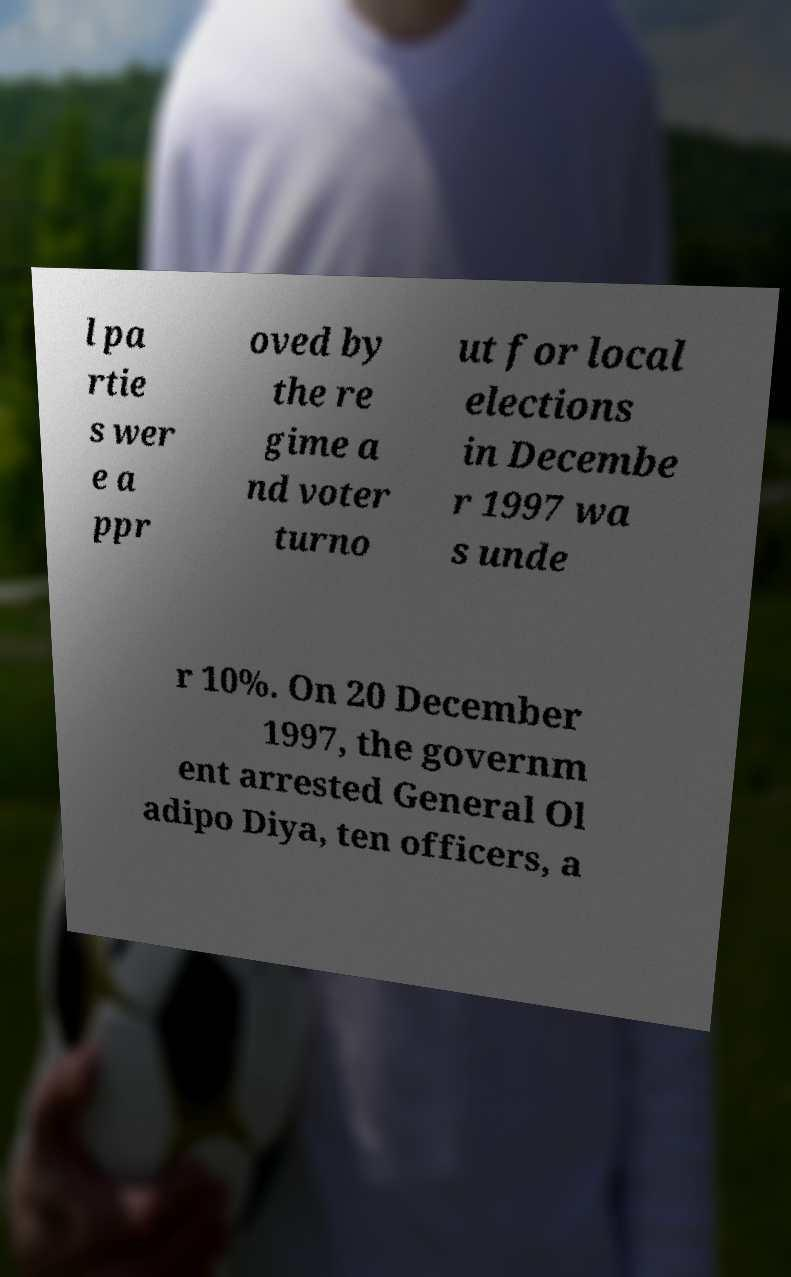Please read and relay the text visible in this image. What does it say? l pa rtie s wer e a ppr oved by the re gime a nd voter turno ut for local elections in Decembe r 1997 wa s unde r 10%. On 20 December 1997, the governm ent arrested General Ol adipo Diya, ten officers, a 